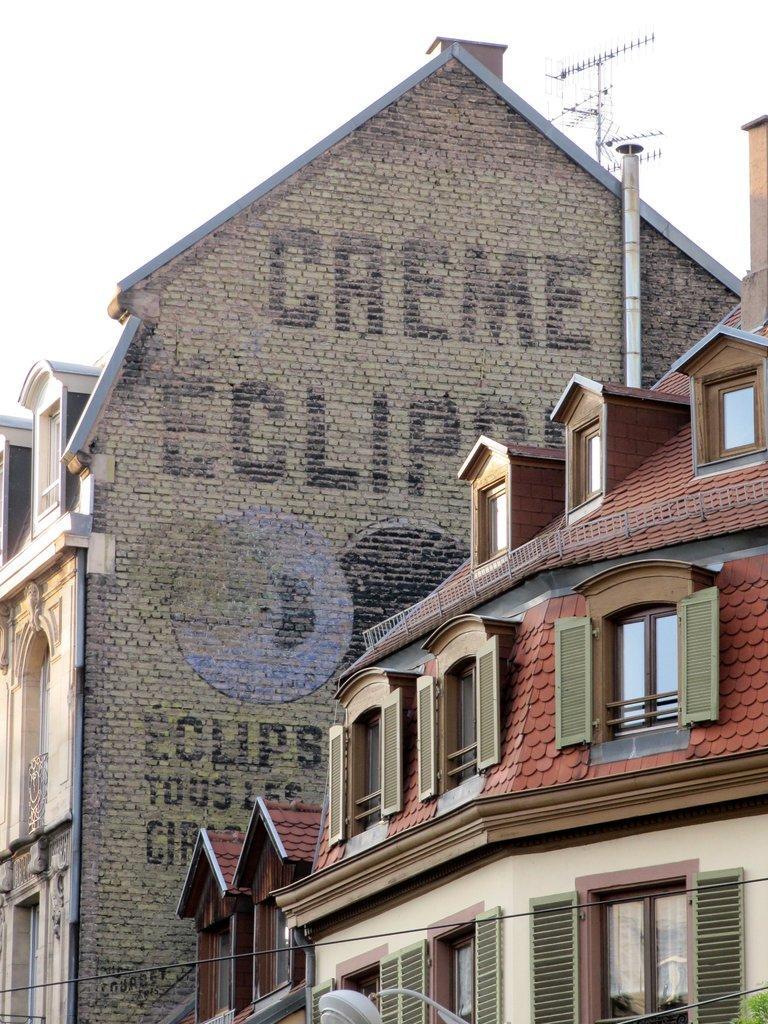In one or two sentences, can you explain what this image depicts? In this picture I can see two buildings with windows, there are words on the wall of a building, there are cables, antenna, and in the background there is sky. 